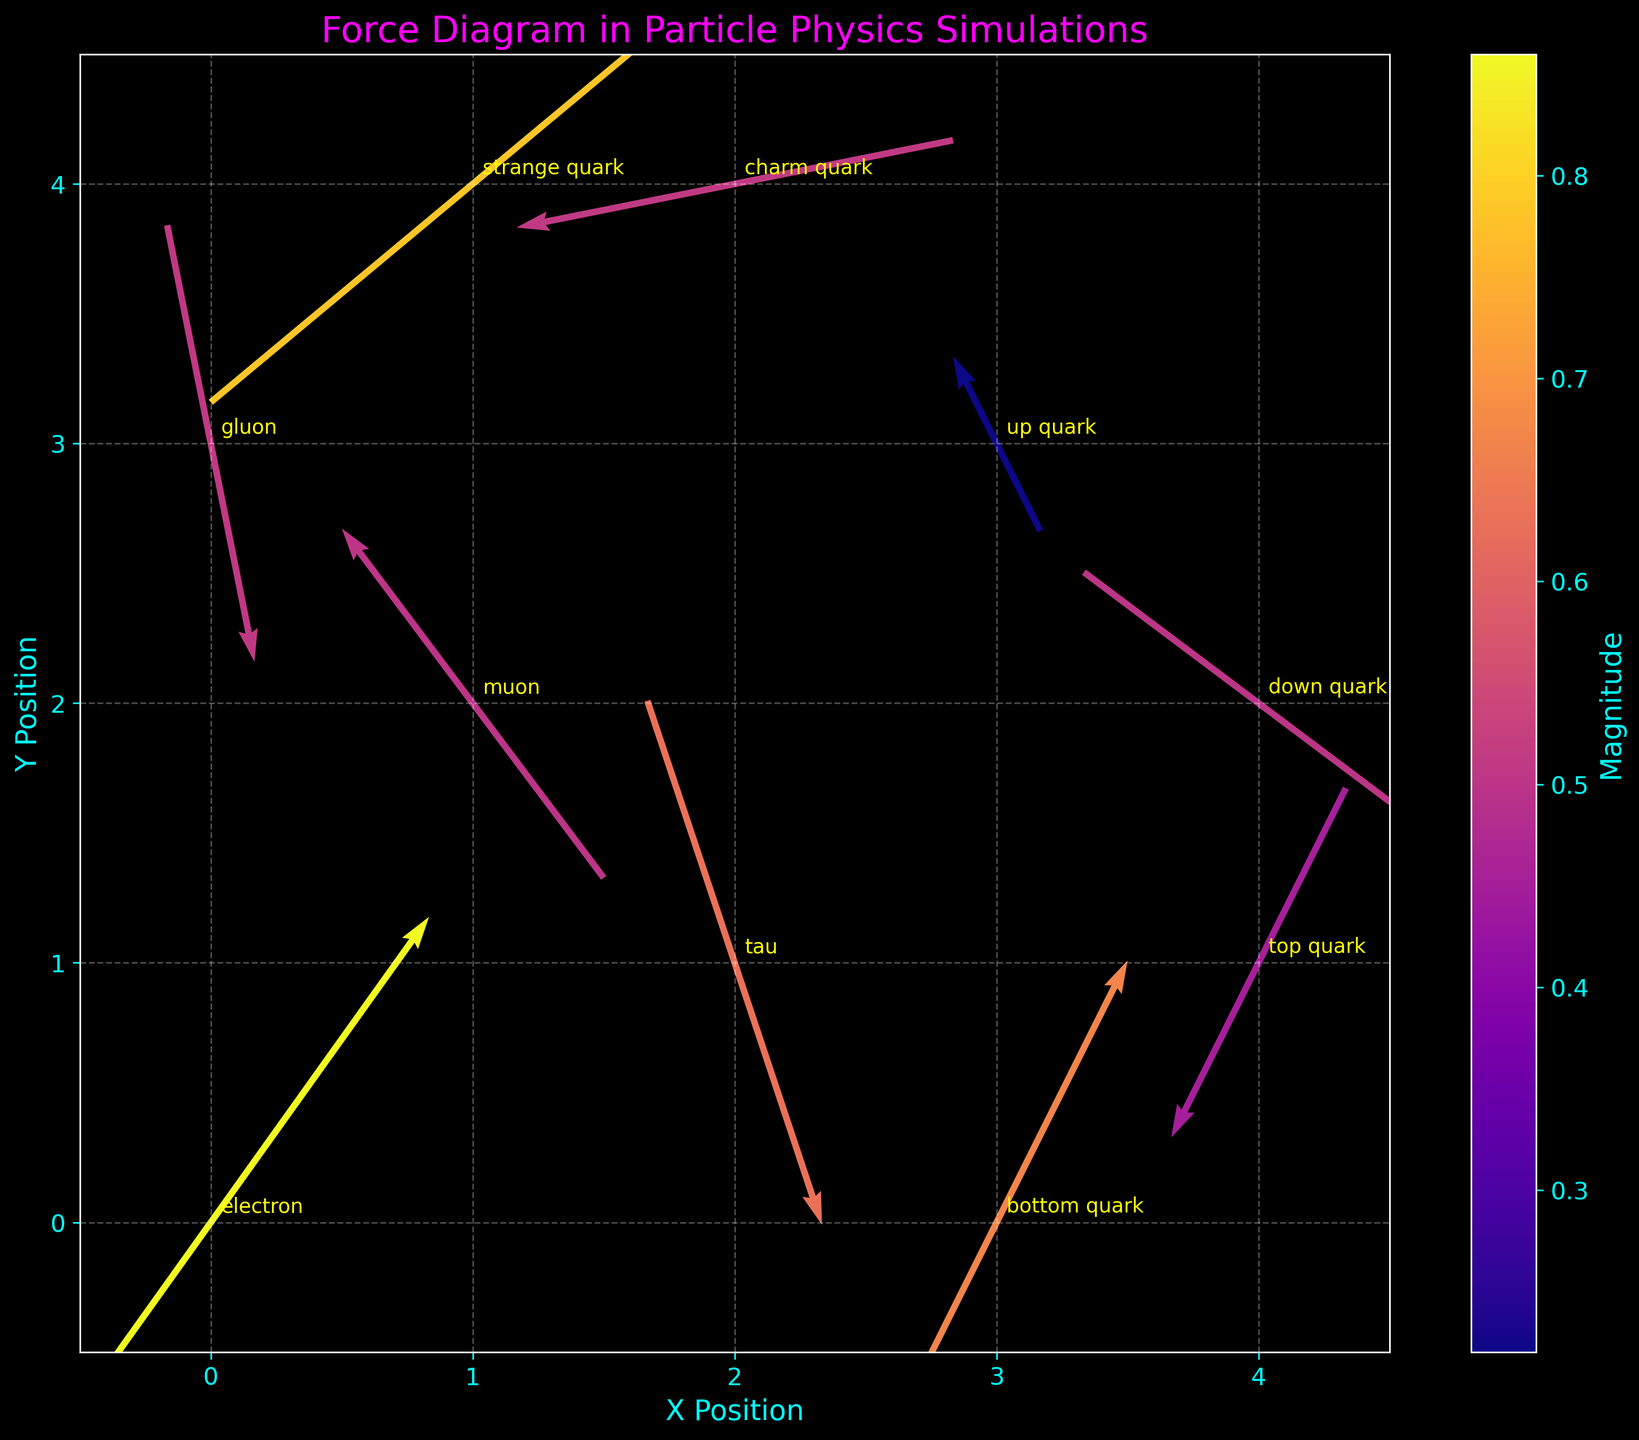What is the title of the plot? The title is located at the top of the plot, usually in a larger and different-colored font to stand out. In this case, it is in a magenta color and specific to particle physics simulations.
Answer: Force Diagram in Particle Physics Simulations What is the color of the labels on the X and Y axes? The X and Y labels are typically colored differently to distinguish them from the grid and data points. In this plot, both labels are colored cyan to maintain visibility against the dark background.
Answer: cyan How many particles are represented in the plot? By counting each unique annotated label in the plot, we can determine the number of different particles. Each label corresponds to a separate particle.
Answer: 10 Which particle is located at the coordinates (3,3)? By looking at the particle labels annotated at each coordinate, we find the particle associated with (3,3).
Answer: up quark Which particle has the highest magnitude of force vector? Magnitudes are shown through color gradients on the quiver plot. By referencing the color bar and identifying the most intense color, we compare it to the annotated particle labels.
Answer: electron What are the coordinates of the strange quark? By locating the label “strange quark” on the plot, we can find its associated coordinates.
Answer: (1,4) Which direction do the force vectors of the down quark and top quark point? By observing the direction of the arrows emanating from the down quark and top quark, we can describe their directions based on the u and v components.
Answer: down quark: southeast, top quark: southwest What is the combined horizontal (x) component of the electron and muon's force vectors? First, find the x components of both particles' force vectors; the electron has 0.5 and the muon has -0.3. Adding them gives the combined value.
Answer: 0.2 Which particle has a force vector pointing primarily in the negative Y direction? By examining the direction of the arrows, see which vector has a significant negative v component.
Answer: gluon Are there any particles whose force vectors are purely horizontal or purely vertical? Purely horizontal vectors would have a v component of 0, while purely vertical would have a u component of 0. By looking at the data and arrows, check if any meet these criteria.
Answer: No 